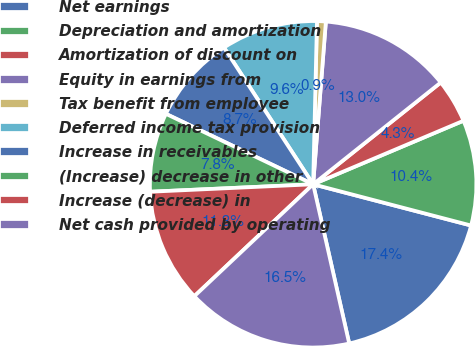Convert chart to OTSL. <chart><loc_0><loc_0><loc_500><loc_500><pie_chart><fcel>Net earnings<fcel>Depreciation and amortization<fcel>Amortization of discount on<fcel>Equity in earnings from<fcel>Tax benefit from employee<fcel>Deferred income tax provision<fcel>Increase in receivables<fcel>(Increase) decrease in other<fcel>Increase (decrease) in<fcel>Net cash provided by operating<nl><fcel>17.39%<fcel>10.43%<fcel>4.35%<fcel>13.04%<fcel>0.87%<fcel>9.57%<fcel>8.7%<fcel>7.83%<fcel>11.3%<fcel>16.52%<nl></chart> 